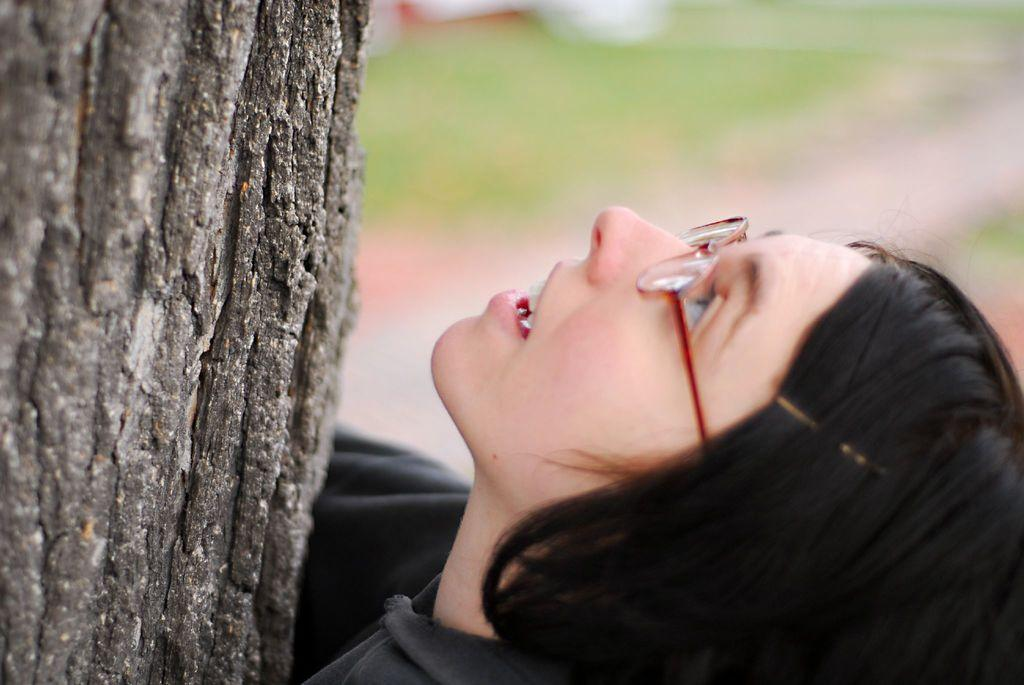What is located on the left side of the image? There is a tree bark on the left side of the image. Who is present in the image? A woman is present in the image. What is the woman doing in the image? The woman is looking at the tree bark. What is the woman wearing on her upper body? The woman is wearing a black color sweater. What accessory is the woman wearing on her face? The woman is wearing spectacles. What type of cake is the woman holding in the image? There is no cake present in the image; the woman is looking at tree bark. How does the acoustics of the room affect the woman's ability to hear in the image? There is no information about the room's acoustics or the woman's ability to hear in the image. 